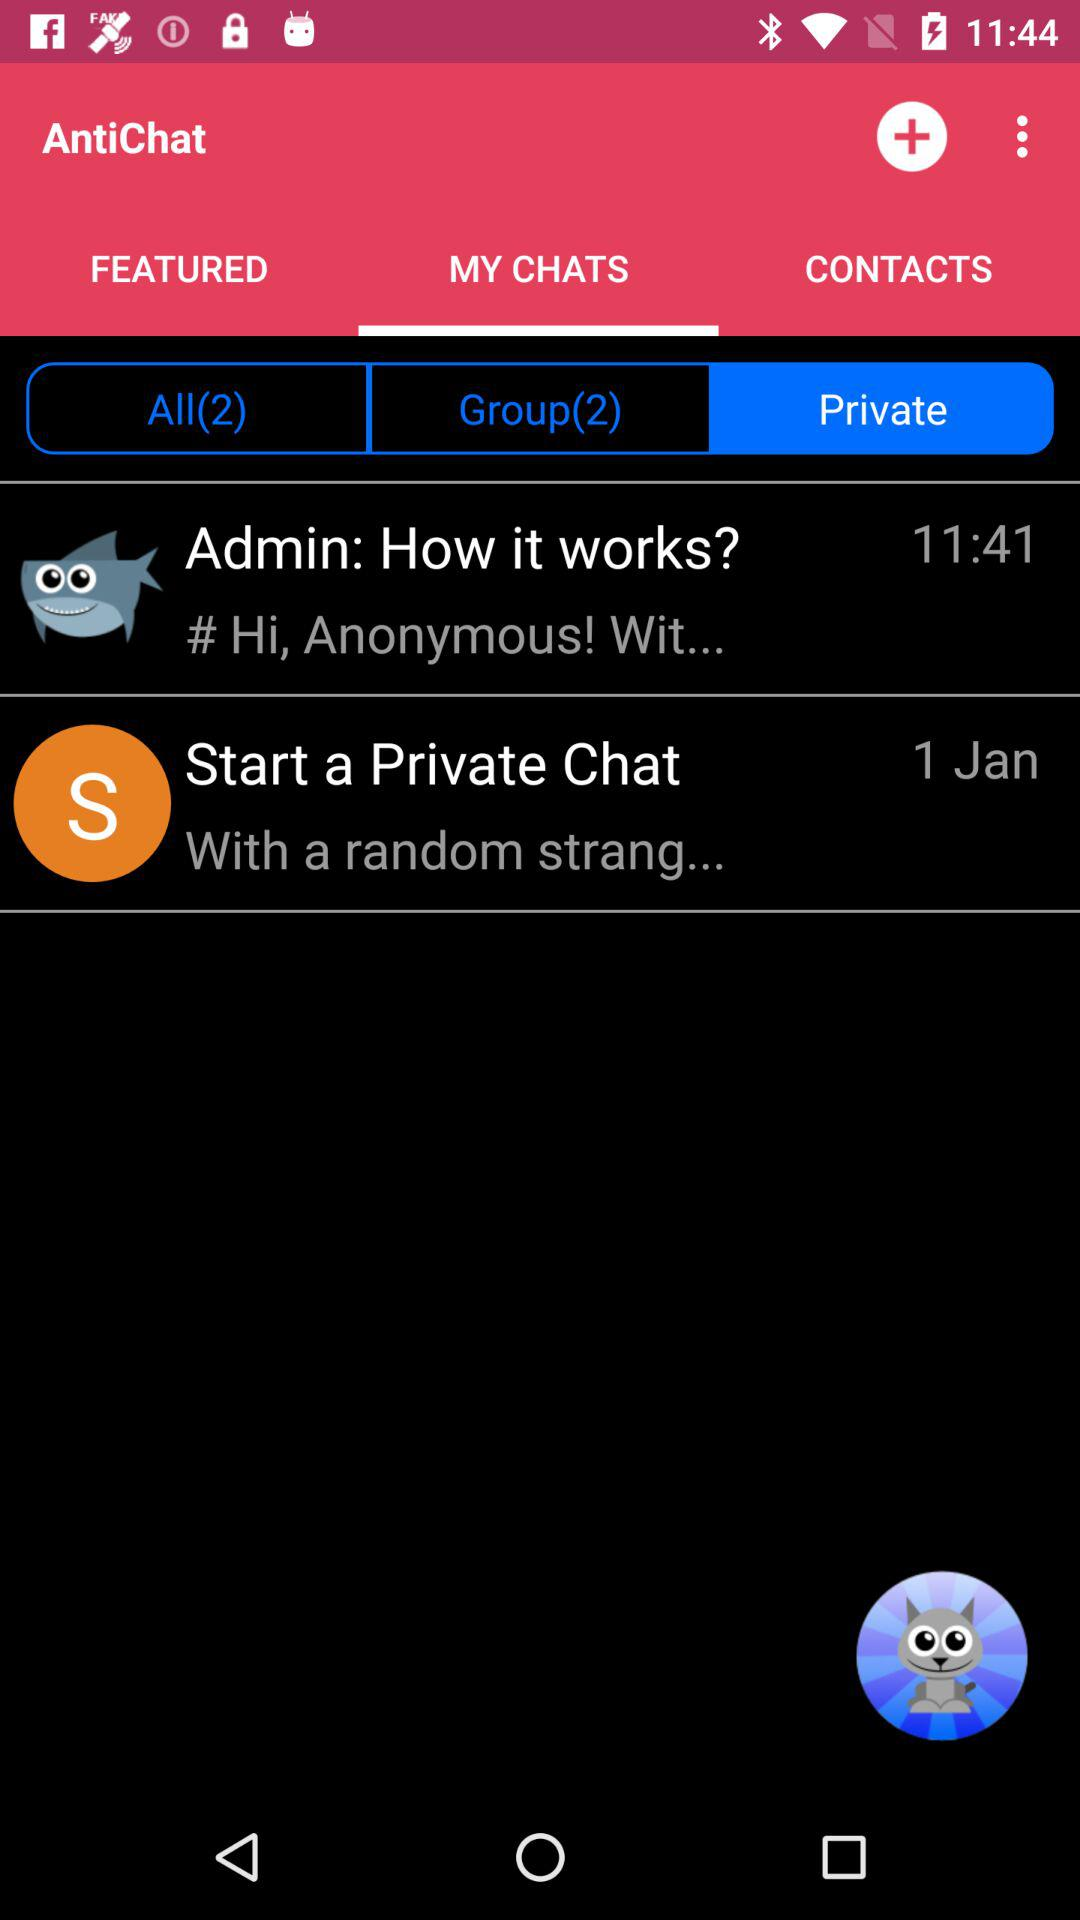Which tab is selected in "AntiChat"? The selected tabs in "AntiChat" are "MY CHATS" and "Private". 